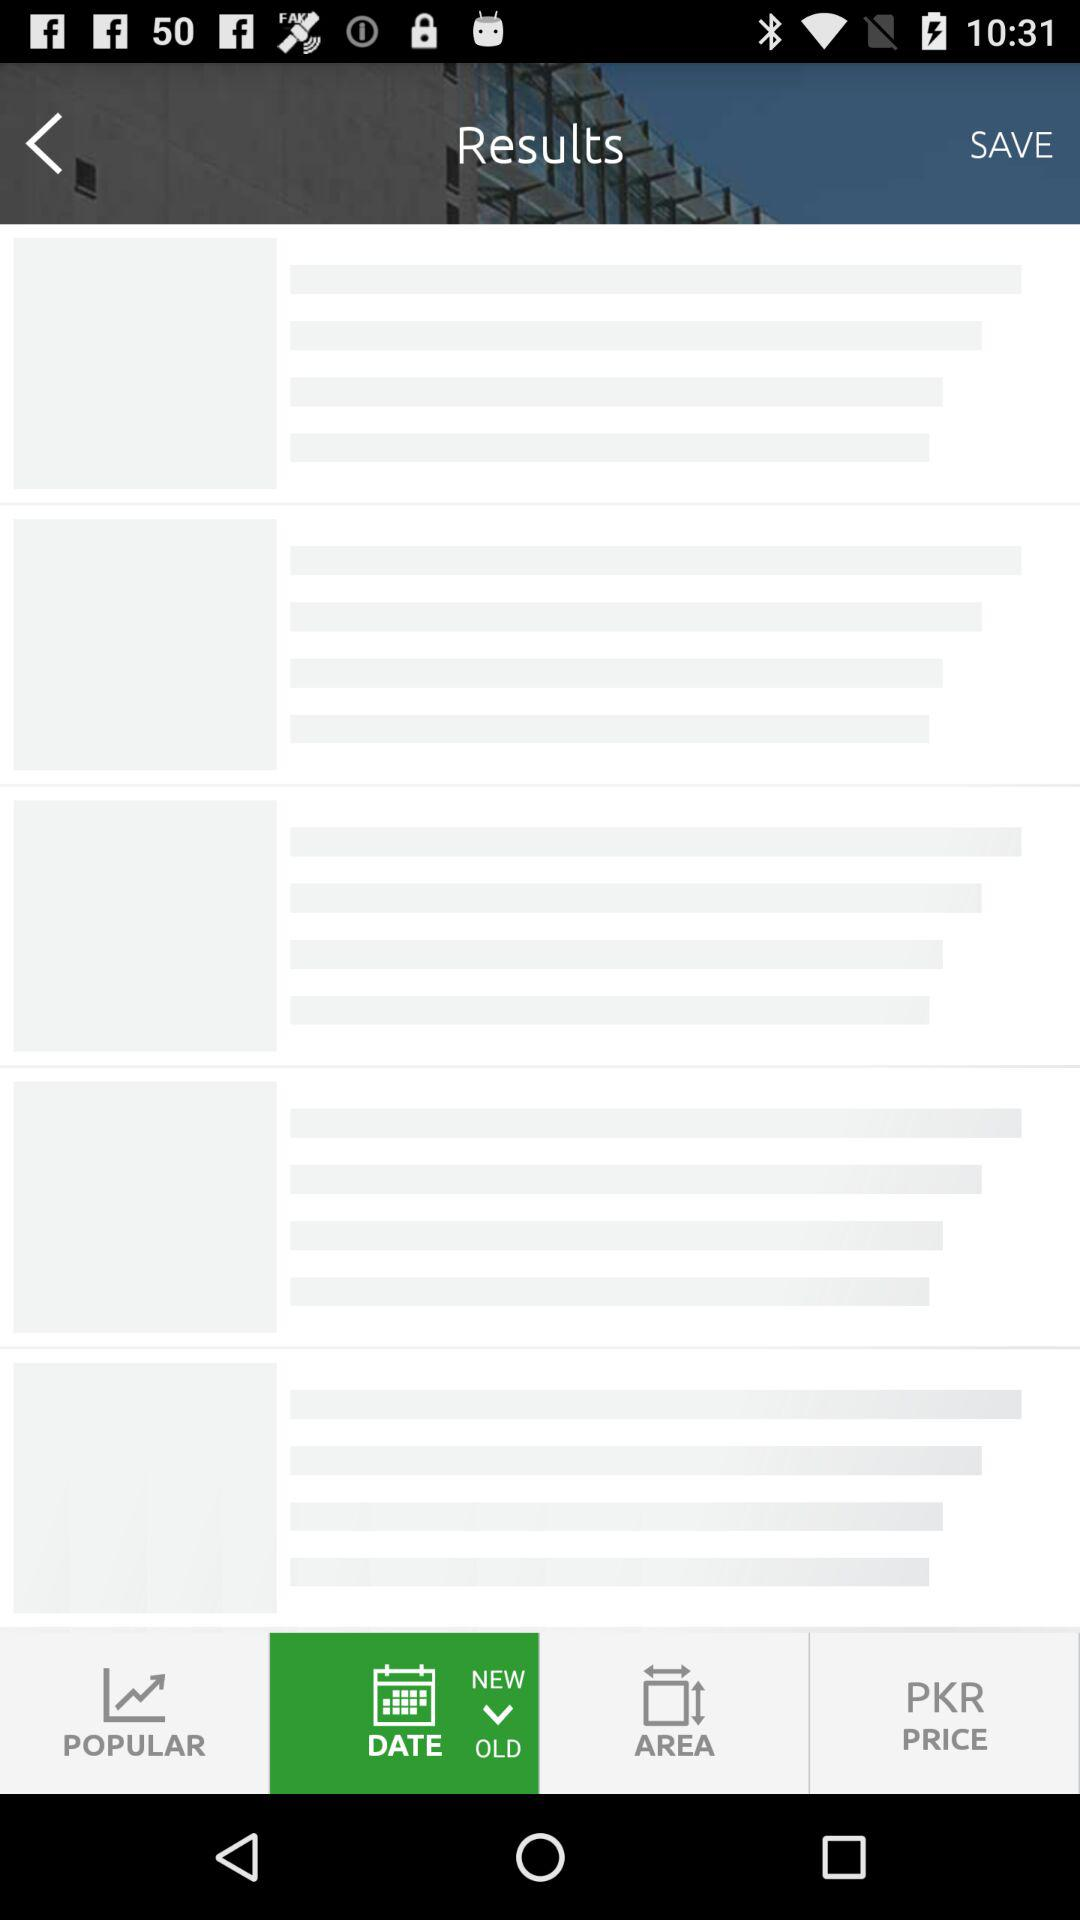When were the details added? The details were added 4 hours ago. 